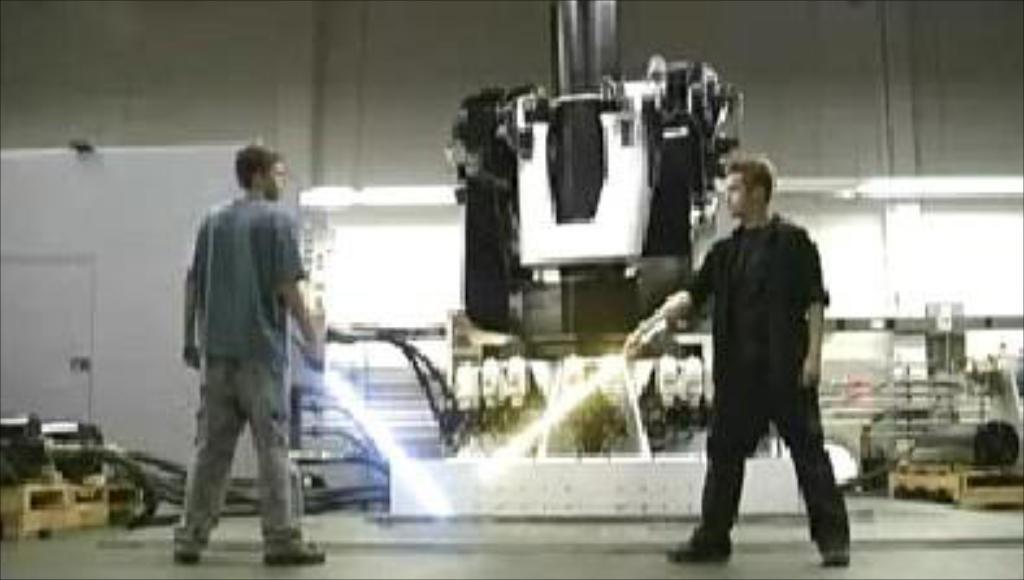How would you summarize this image in a sentence or two? In this image there are two men standing, they are holding an object, there is an object towards the top of the image that looks like a machine, there are objects towards the right of the image, there are objects towards the left of the image, there is a board towards the left of the image, there is floor towards the bottom of the image, at the background of the image there is a wall. 